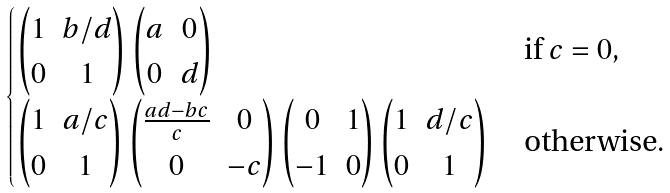<formula> <loc_0><loc_0><loc_500><loc_500>\begin{cases} \begin{pmatrix} 1 & b / d \\ 0 & 1 \end{pmatrix} \begin{pmatrix} a & 0 \\ 0 & d \end{pmatrix} & \text { if } c = 0 , \\ \begin{pmatrix} 1 & a / c \\ 0 & 1 \end{pmatrix} \begin{pmatrix} \frac { a d - b c } { c } & 0 \\ 0 & - c \end{pmatrix} \begin{pmatrix} 0 & 1 \\ - 1 & 0 \end{pmatrix} \begin{pmatrix} 1 & d / c \\ 0 & 1 \end{pmatrix} & \text { otherwise} . \end{cases}</formula> 